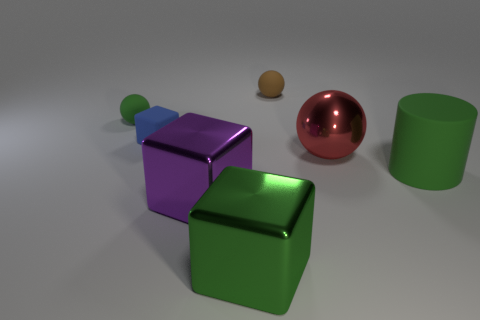Add 1 large gray rubber things. How many objects exist? 8 Subtract all large metal spheres. How many spheres are left? 2 Subtract 1 cubes. How many cubes are left? 2 Subtract all gray blocks. How many red balls are left? 1 Subtract all matte objects. Subtract all big brown matte cylinders. How many objects are left? 3 Add 6 purple objects. How many purple objects are left? 7 Add 6 big green metallic cubes. How many big green metallic cubes exist? 7 Subtract 0 purple balls. How many objects are left? 7 Subtract all cubes. How many objects are left? 4 Subtract all yellow balls. Subtract all yellow cubes. How many balls are left? 3 